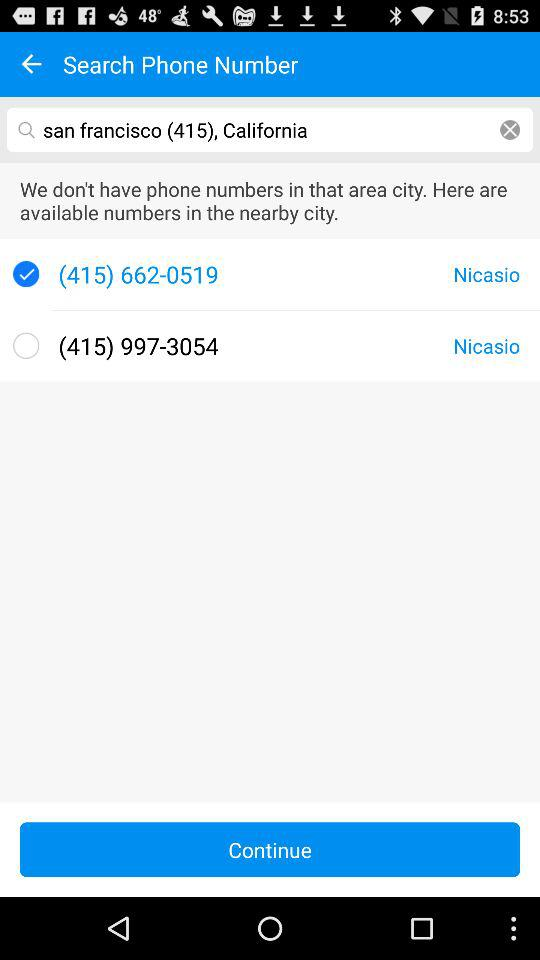How many results are there for the search query?
Answer the question using a single word or phrase. 2 